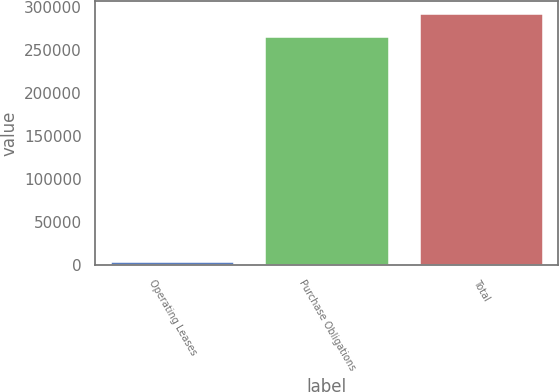Convert chart to OTSL. <chart><loc_0><loc_0><loc_500><loc_500><bar_chart><fcel>Operating Leases<fcel>Purchase Obligations<fcel>Total<nl><fcel>3357<fcel>265409<fcel>291950<nl></chart> 